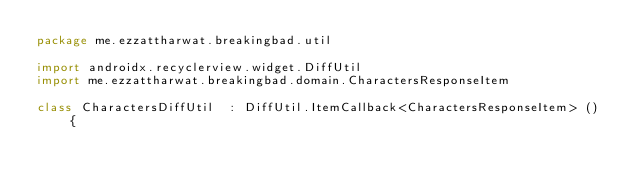Convert code to text. <code><loc_0><loc_0><loc_500><loc_500><_Kotlin_>package me.ezzattharwat.breakingbad.util

import androidx.recyclerview.widget.DiffUtil
import me.ezzattharwat.breakingbad.domain.CharactersResponseItem

class CharactersDiffUtil  : DiffUtil.ItemCallback<CharactersResponseItem> () {
</code> 